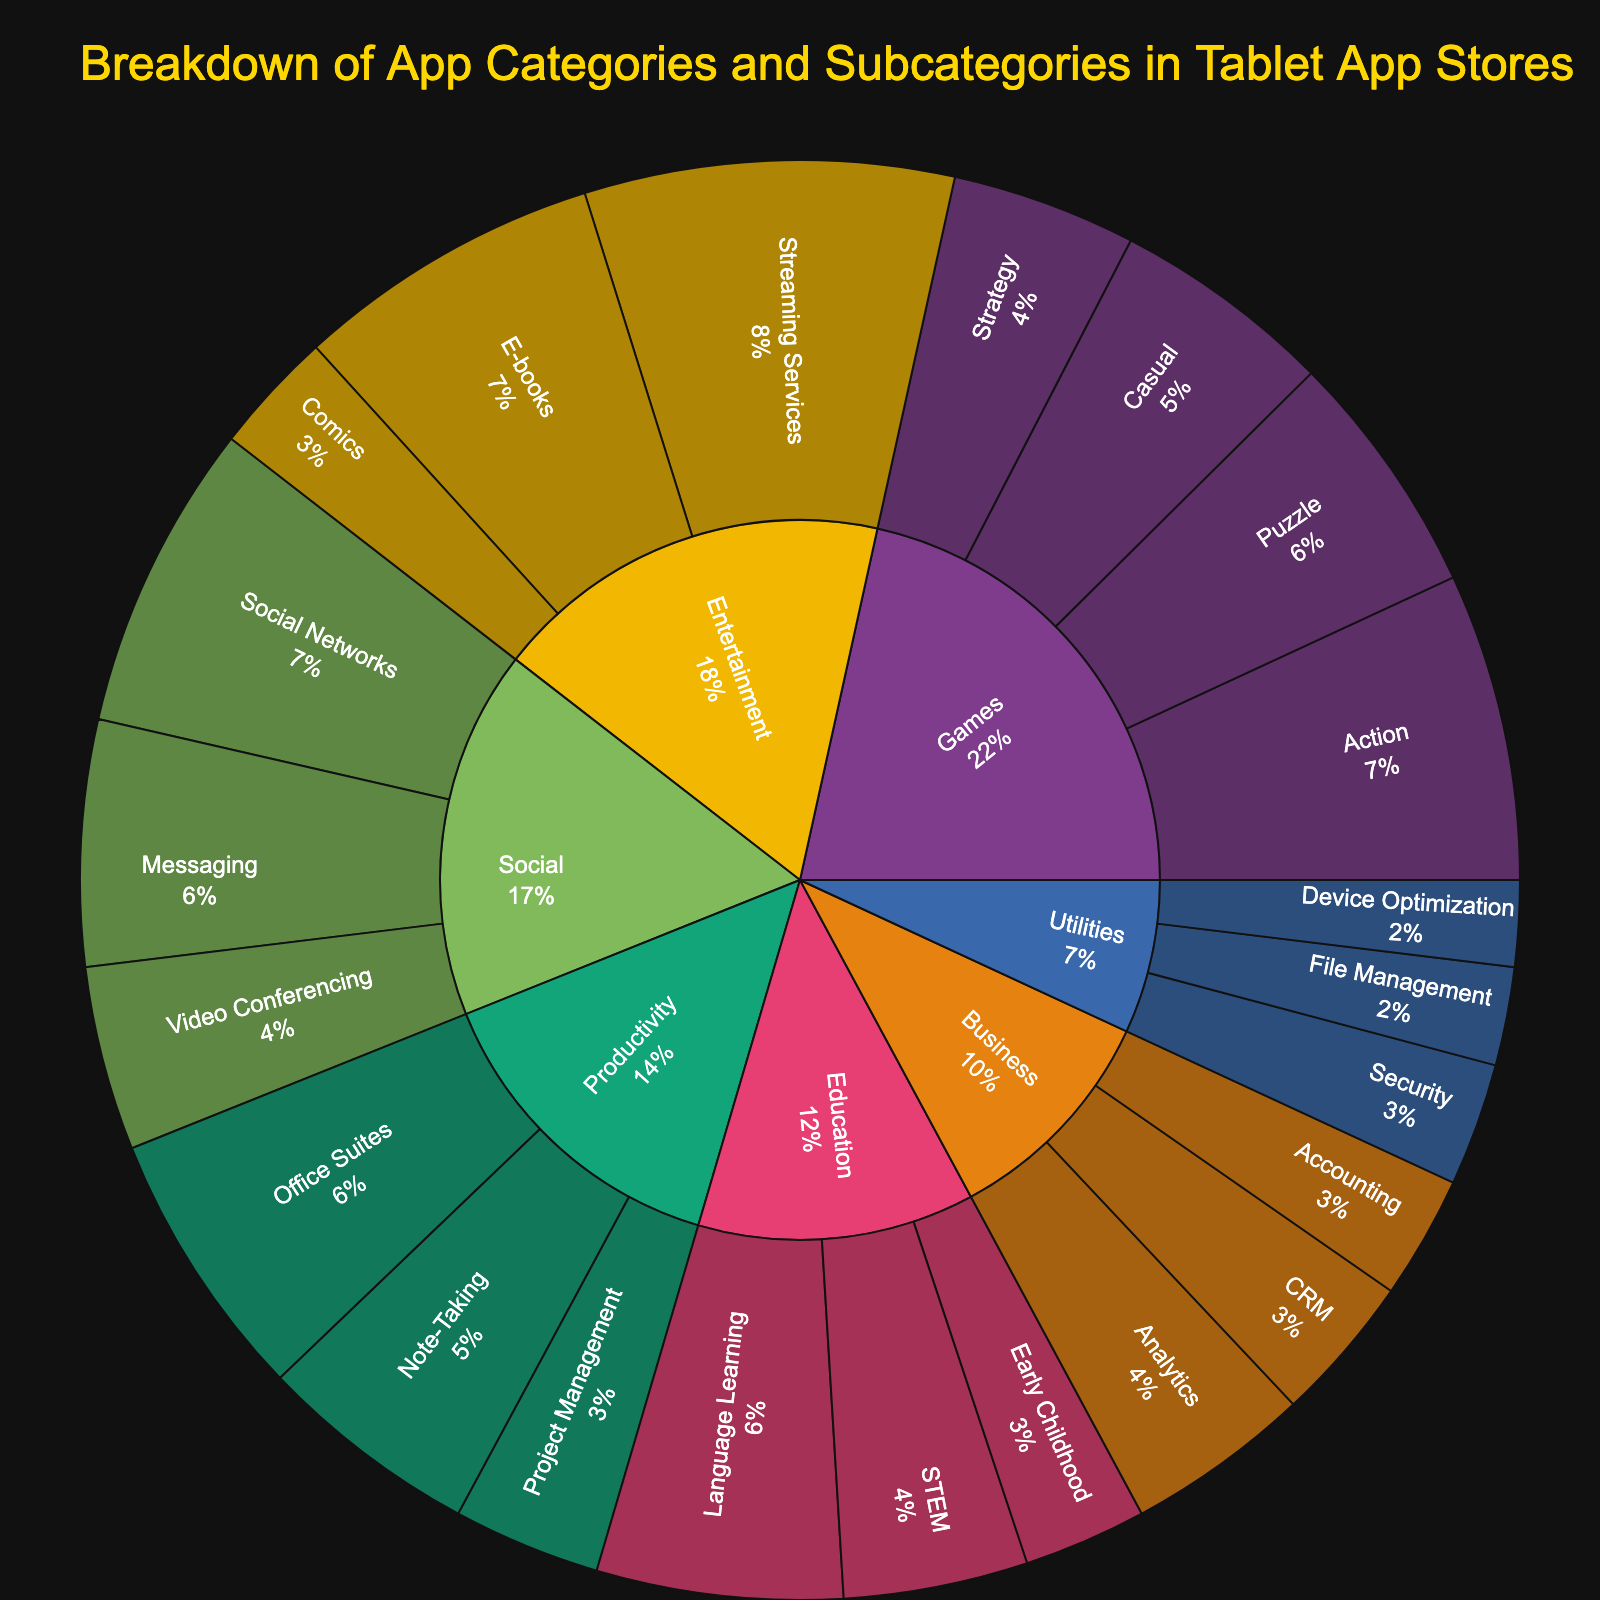What is the title of the Sunburst Plot? The title can be found at the top of the sunburst plot.
Answer: Breakdown of App Categories and Subcategories in Tablet App Stores Which category has the largest total value? Look for the largest section in the outermost ring of the sunburst plot where each category is represented by different colors.
Answer: Entertainment What percentage of the total value do Games constitute? Sum the values of all subcategories under Games and divide by the total value of all categories, then multiply by 100. The specific segments for Games subcategories can be found in the visual annotations.
Answer: 21.5% Which category has the smallest number of subcategories? Count the number of subcategories in each category by looking at the segments branching out from each main category.
Answer: Utilities How many subcategories does the Productivity category have? Identify the 'Productivity' category and count the number of segments branching out from it.
Answer: 3 What is the combined value of all Entertainment subcategories? Sum the values of the subcategories under Entertainment: Streaming Services (30) + E-books (25) + Comics (10).
Answer: 65 Which subcategory within the Social category has the highest value? Find the Social category and compare the values of its subcategories: Messaging, Social Networks, and Video Conferencing.
Answer: Social Networks How does the value of the Strategy subcategory in Games compare to that of the CRM subcategory in Business? Compare the values of "Strategy" under Games (15) and "CRM" under Business (12).
Answer: Strategy has a higher value What is the average value of app categories in the Education category? Find the subcategories within Education and calculate their average: (Language Learning (20) + STEM (15) + Early Childhood (10)) / 3 = 15.
Answer: 15 Which category has the most subcategories with values less than 10? Identify subcategories under each main category and count those with values less than 10.
Answer: Utilities 